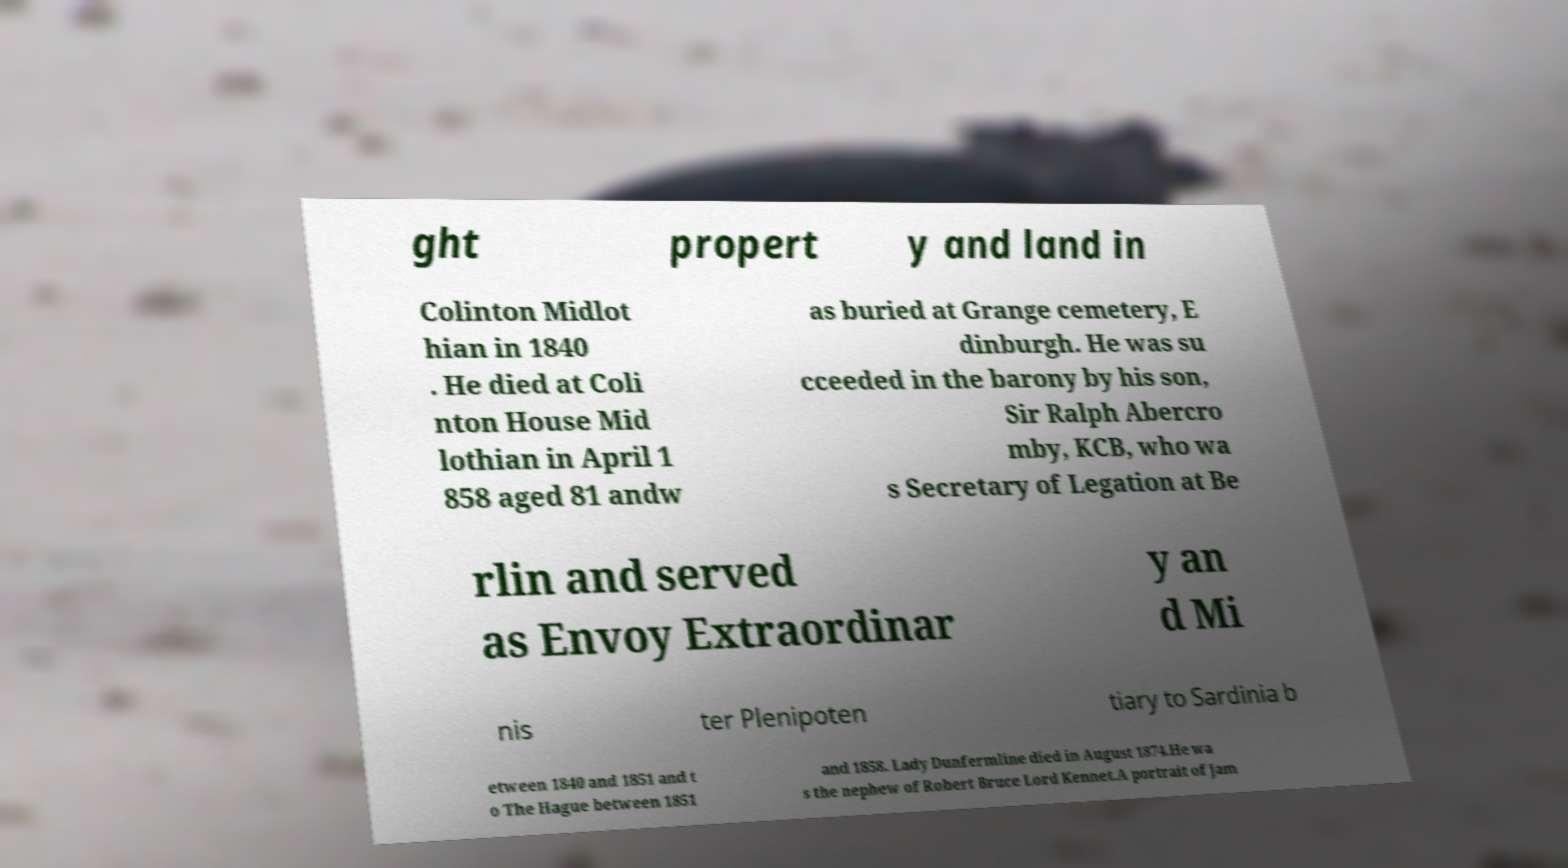Could you extract and type out the text from this image? ght propert y and land in Colinton Midlot hian in 1840 . He died at Coli nton House Mid lothian in April 1 858 aged 81 andw as buried at Grange cemetery, E dinburgh. He was su cceeded in the barony by his son, Sir Ralph Abercro mby, KCB, who wa s Secretary of Legation at Be rlin and served as Envoy Extraordinar y an d Mi nis ter Plenipoten tiary to Sardinia b etween 1840 and 1851 and t o The Hague between 1851 and 1858. Lady Dunfermline died in August 1874.He wa s the nephew of Robert Bruce Lord Kennet.A portrait of Jam 